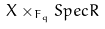<formula> <loc_0><loc_0><loc_500><loc_500>X \times _ { F _ { q } } S p e c R</formula> 